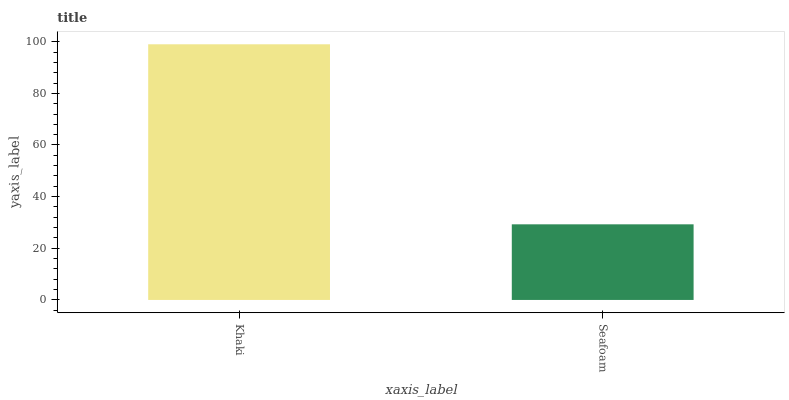Is Seafoam the minimum?
Answer yes or no. Yes. Is Khaki the maximum?
Answer yes or no. Yes. Is Seafoam the maximum?
Answer yes or no. No. Is Khaki greater than Seafoam?
Answer yes or no. Yes. Is Seafoam less than Khaki?
Answer yes or no. Yes. Is Seafoam greater than Khaki?
Answer yes or no. No. Is Khaki less than Seafoam?
Answer yes or no. No. Is Khaki the high median?
Answer yes or no. Yes. Is Seafoam the low median?
Answer yes or no. Yes. Is Seafoam the high median?
Answer yes or no. No. Is Khaki the low median?
Answer yes or no. No. 